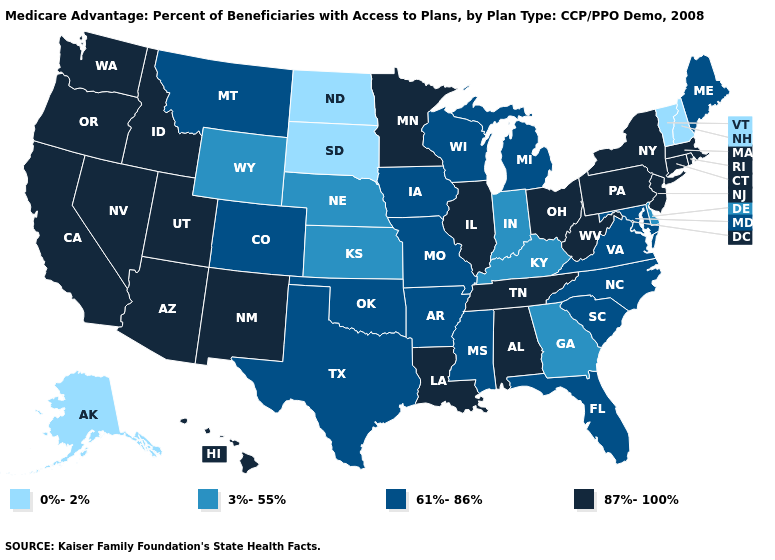What is the lowest value in states that border New Mexico?
Be succinct. 61%-86%. Among the states that border Minnesota , which have the lowest value?
Be succinct. North Dakota, South Dakota. How many symbols are there in the legend?
Write a very short answer. 4. What is the highest value in the South ?
Quick response, please. 87%-100%. What is the value of Maryland?
Be succinct. 61%-86%. What is the highest value in states that border Missouri?
Short answer required. 87%-100%. Does Minnesota have the lowest value in the USA?
Quick response, please. No. Name the states that have a value in the range 87%-100%?
Give a very brief answer. Alabama, Arizona, California, Connecticut, Hawaii, Idaho, Illinois, Louisiana, Massachusetts, Minnesota, New Jersey, New Mexico, Nevada, New York, Ohio, Oregon, Pennsylvania, Rhode Island, Tennessee, Utah, Washington, West Virginia. What is the value of North Carolina?
Concise answer only. 61%-86%. What is the value of Georgia?
Answer briefly. 3%-55%. Does Mississippi have the same value as Hawaii?
Short answer required. No. What is the value of Washington?
Short answer required. 87%-100%. What is the value of Massachusetts?
Keep it brief. 87%-100%. Name the states that have a value in the range 3%-55%?
Quick response, please. Delaware, Georgia, Indiana, Kansas, Kentucky, Nebraska, Wyoming. Name the states that have a value in the range 0%-2%?
Keep it brief. Alaska, North Dakota, New Hampshire, South Dakota, Vermont. 